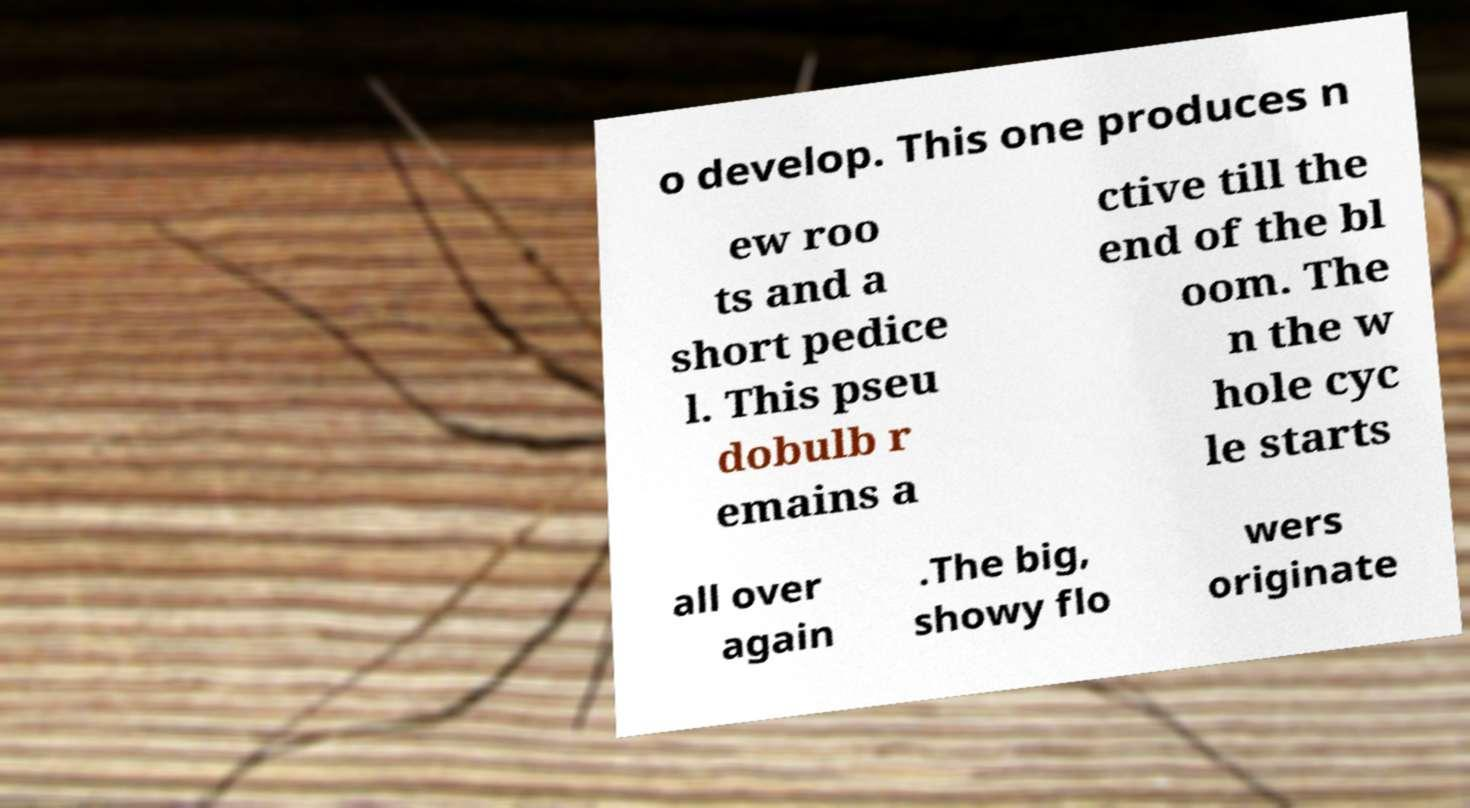There's text embedded in this image that I need extracted. Can you transcribe it verbatim? o develop. This one produces n ew roo ts and a short pedice l. This pseu dobulb r emains a ctive till the end of the bl oom. The n the w hole cyc le starts all over again .The big, showy flo wers originate 